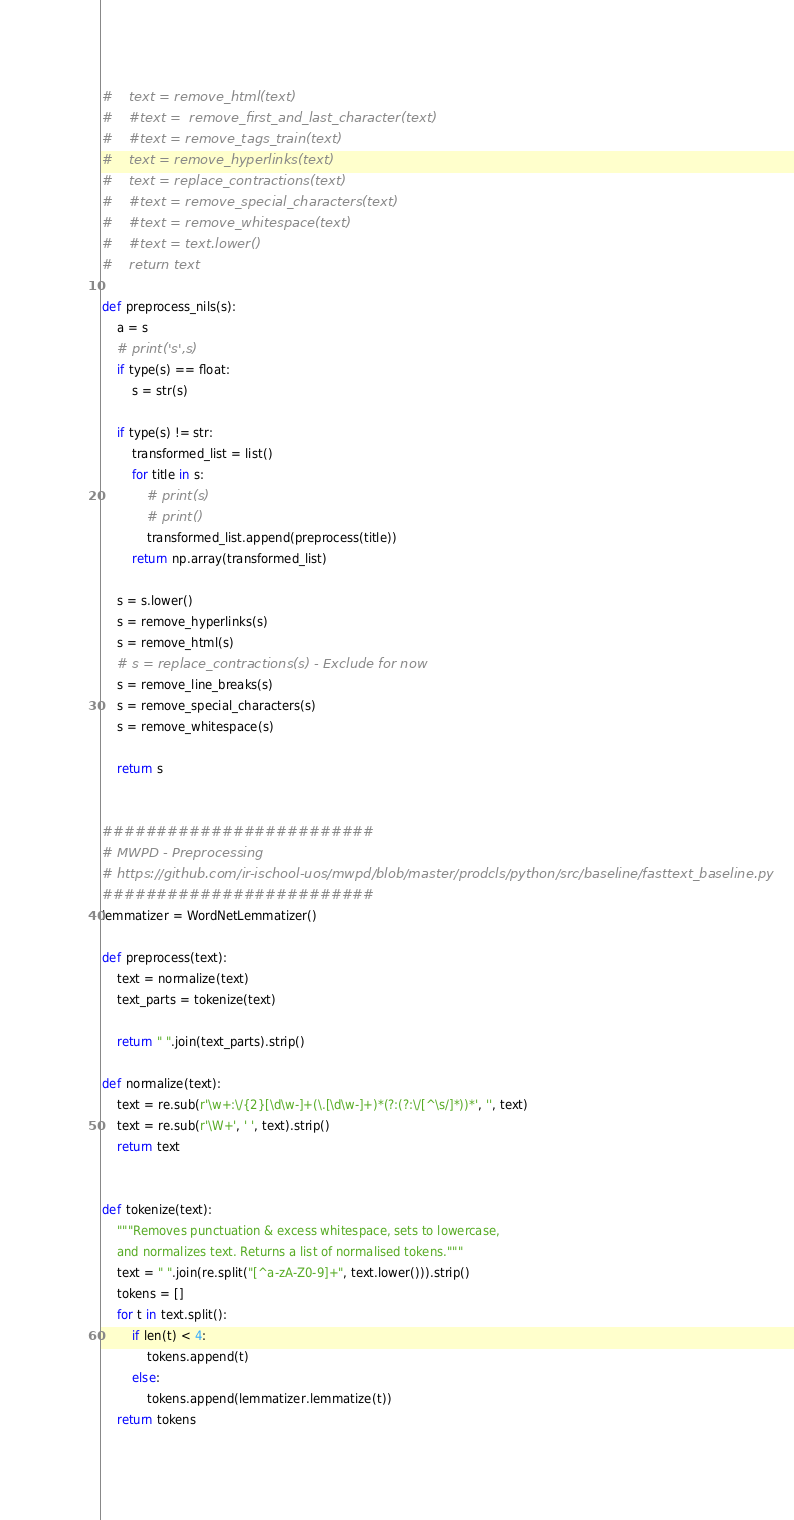<code> <loc_0><loc_0><loc_500><loc_500><_Python_>#    text = remove_html(text)
#    #text =  remove_first_and_last_character(text)
#    #text = remove_tags_train(text)
#    text = remove_hyperlinks(text)
#    text = replace_contractions(text)
#    #text = remove_special_characters(text)
#    #text = remove_whitespace(text)
#    #text = text.lower()
#    return text

def preprocess_nils(s):
    a = s
    # print('s',s)
    if type(s) == float:
        s = str(s)

    if type(s) != str:
        transformed_list = list()
        for title in s:
            # print(s)
            # print()
            transformed_list.append(preprocess(title))
        return np.array(transformed_list)

    s = s.lower()
    s = remove_hyperlinks(s)
    s = remove_html(s)
    # s = replace_contractions(s) - Exclude for now
    s = remove_line_breaks(s)
    s = remove_special_characters(s)
    s = remove_whitespace(s)

    return s


#########################
# MWPD - Preprocessing
# https://github.com/ir-ischool-uos/mwpd/blob/master/prodcls/python/src/baseline/fasttext_baseline.py
#########################
lemmatizer = WordNetLemmatizer()

def preprocess(text):
    text = normalize(text)
    text_parts = tokenize(text)

    return " ".join(text_parts).strip()

def normalize(text):
    text = re.sub(r'\w+:\/{2}[\d\w-]+(\.[\d\w-]+)*(?:(?:\/[^\s/]*))*', '', text)
    text = re.sub(r'\W+', ' ', text).strip()
    return text


def tokenize(text):
    """Removes punctuation & excess whitespace, sets to lowercase,
    and normalizes text. Returns a list of normalised tokens."""
    text = " ".join(re.split("[^a-zA-Z0-9]+", text.lower())).strip()
    tokens = []
    for t in text.split():
        if len(t) < 4:
            tokens.append(t)
        else:
            tokens.append(lemmatizer.lemmatize(t))
    return tokens
</code> 